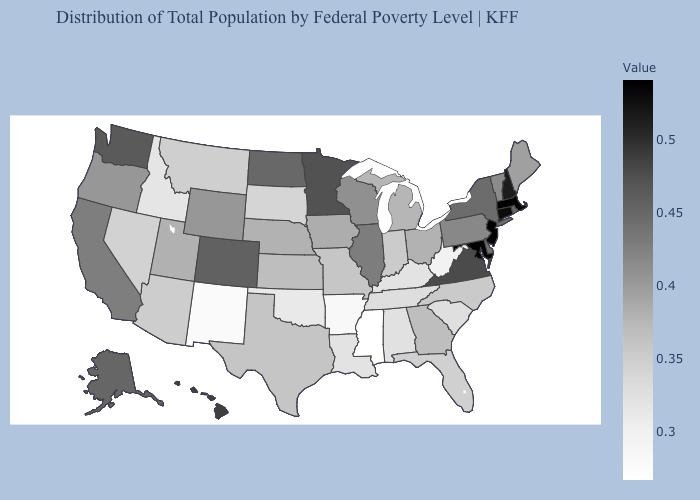Is the legend a continuous bar?
Keep it brief. Yes. Is the legend a continuous bar?
Short answer required. Yes. Among the states that border Connecticut , which have the highest value?
Write a very short answer. Massachusetts. 